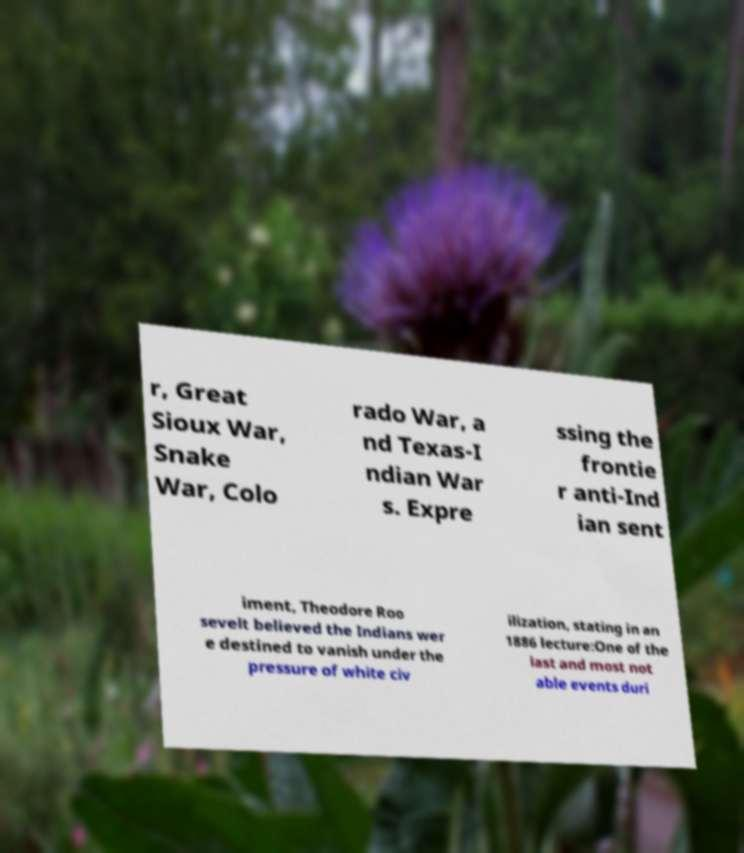For documentation purposes, I need the text within this image transcribed. Could you provide that? r, Great Sioux War, Snake War, Colo rado War, a nd Texas-I ndian War s. Expre ssing the frontie r anti-Ind ian sent iment, Theodore Roo sevelt believed the Indians wer e destined to vanish under the pressure of white civ ilization, stating in an 1886 lecture:One of the last and most not able events duri 